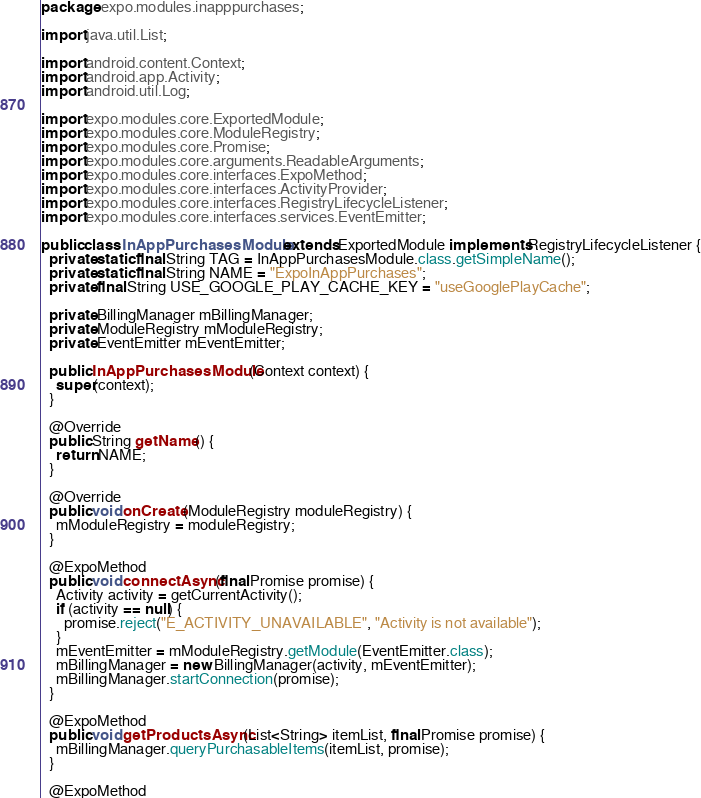<code> <loc_0><loc_0><loc_500><loc_500><_Java_>package expo.modules.inapppurchases;

import java.util.List;

import android.content.Context;
import android.app.Activity;
import android.util.Log;

import expo.modules.core.ExportedModule;
import expo.modules.core.ModuleRegistry;
import expo.modules.core.Promise;
import expo.modules.core.arguments.ReadableArguments;
import expo.modules.core.interfaces.ExpoMethod;
import expo.modules.core.interfaces.ActivityProvider;
import expo.modules.core.interfaces.RegistryLifecycleListener;
import expo.modules.core.interfaces.services.EventEmitter;

public class InAppPurchasesModule extends ExportedModule implements RegistryLifecycleListener {
  private static final String TAG = InAppPurchasesModule.class.getSimpleName();
  private static final String NAME = "ExpoInAppPurchases";
  private final String USE_GOOGLE_PLAY_CACHE_KEY = "useGooglePlayCache";

  private BillingManager mBillingManager;
  private ModuleRegistry mModuleRegistry;
  private EventEmitter mEventEmitter;

  public InAppPurchasesModule(Context context) {
    super(context);
  }

  @Override
  public String getName() {
    return NAME;
  }

  @Override
  public void onCreate(ModuleRegistry moduleRegistry) {
    mModuleRegistry = moduleRegistry;
  }

  @ExpoMethod
  public void connectAsync(final Promise promise) {
    Activity activity = getCurrentActivity();
    if (activity == null) {
      promise.reject("E_ACTIVITY_UNAVAILABLE", "Activity is not available");
    }
    mEventEmitter = mModuleRegistry.getModule(EventEmitter.class);
    mBillingManager = new BillingManager(activity, mEventEmitter);
    mBillingManager.startConnection(promise);
  }

  @ExpoMethod
  public void getProductsAsync(List<String> itemList, final Promise promise) {
    mBillingManager.queryPurchasableItems(itemList, promise);
  }

  @ExpoMethod</code> 